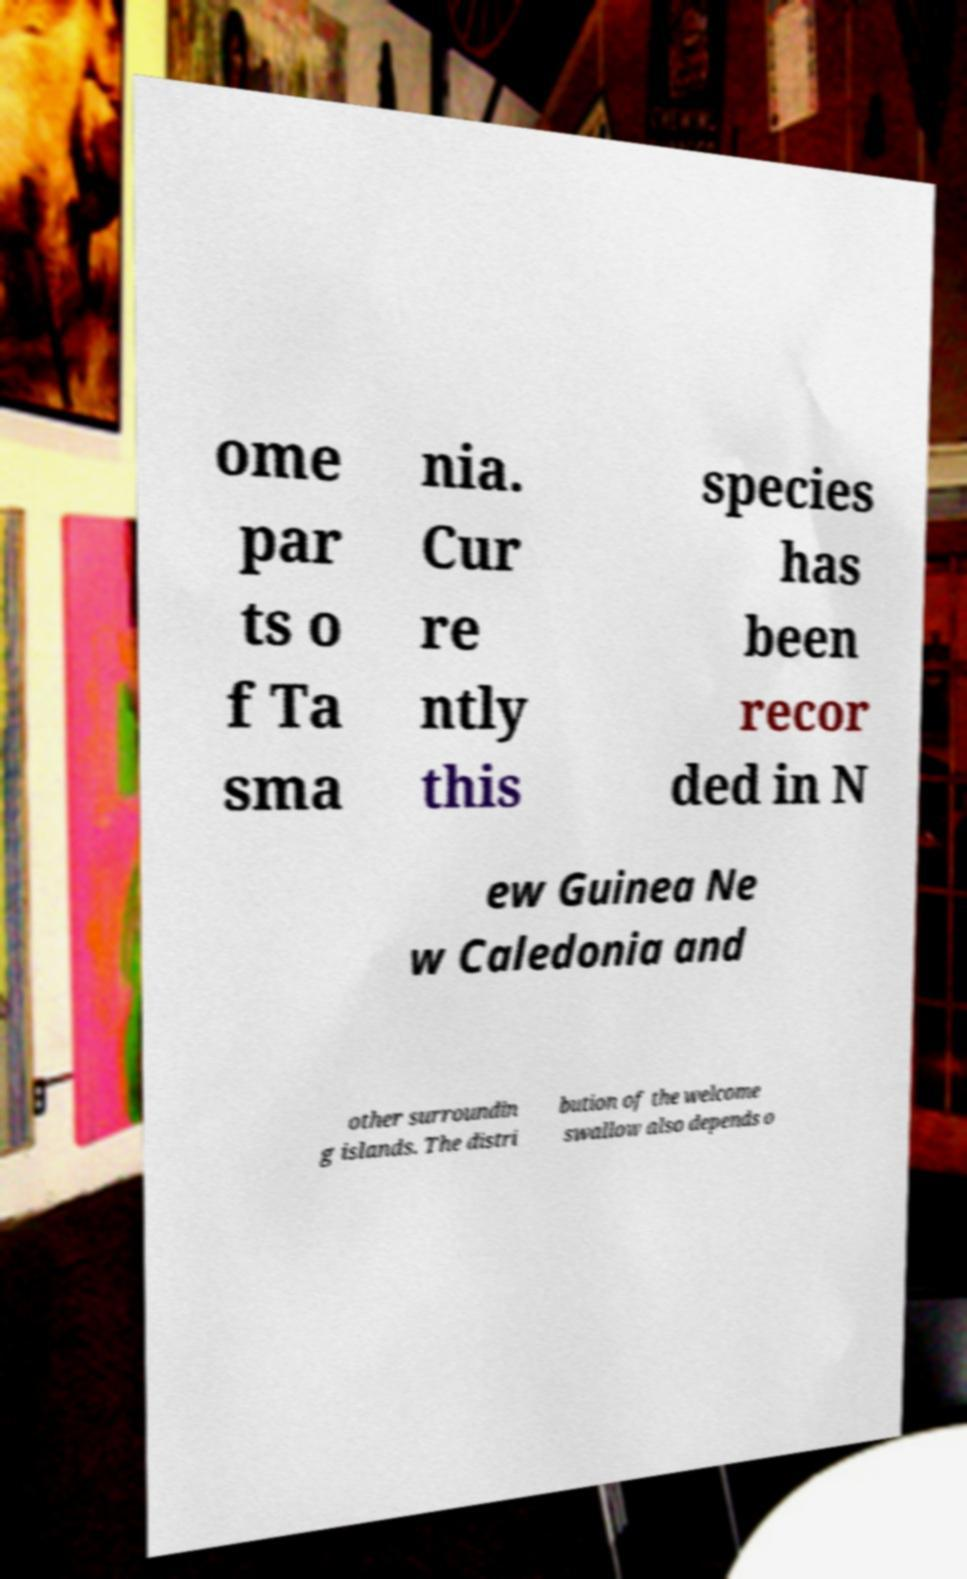There's text embedded in this image that I need extracted. Can you transcribe it verbatim? ome par ts o f Ta sma nia. Cur re ntly this species has been recor ded in N ew Guinea Ne w Caledonia and other surroundin g islands. The distri bution of the welcome swallow also depends o 